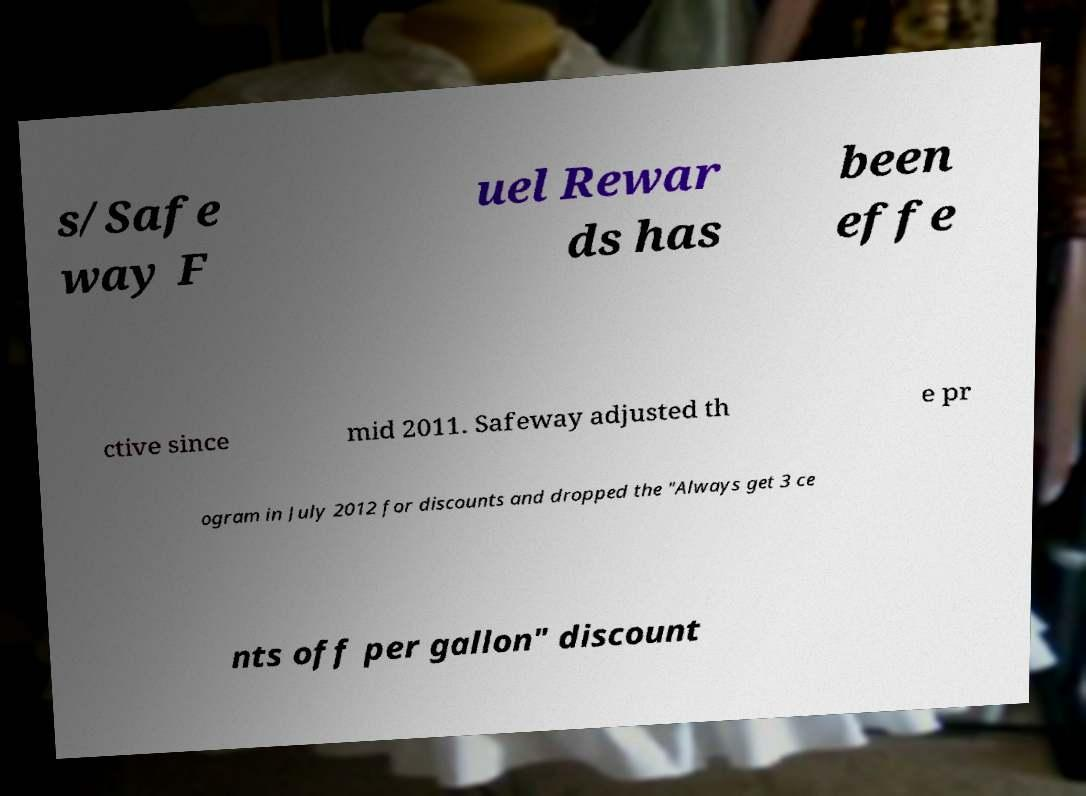Could you assist in decoding the text presented in this image and type it out clearly? s/Safe way F uel Rewar ds has been effe ctive since mid 2011. Safeway adjusted th e pr ogram in July 2012 for discounts and dropped the "Always get 3 ce nts off per gallon" discount 